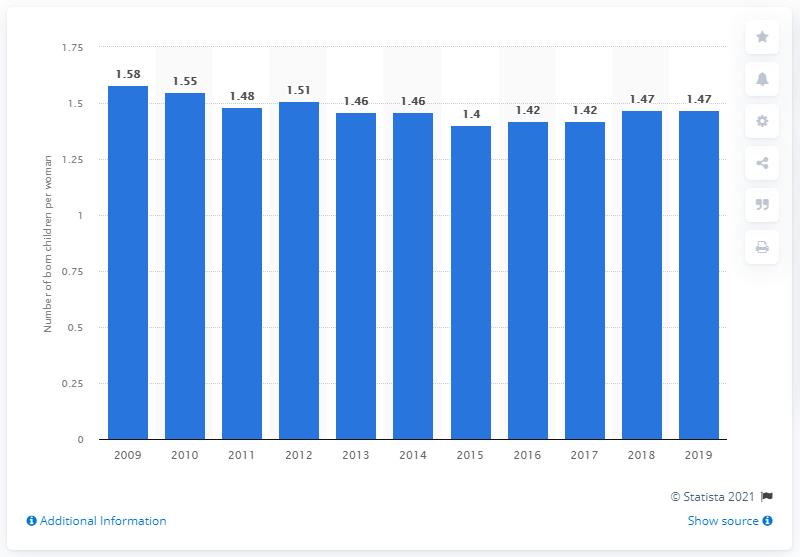Mention a couple of crucial points in this snapshot. In 2019, the fertility rate in Croatia was 1.47. 